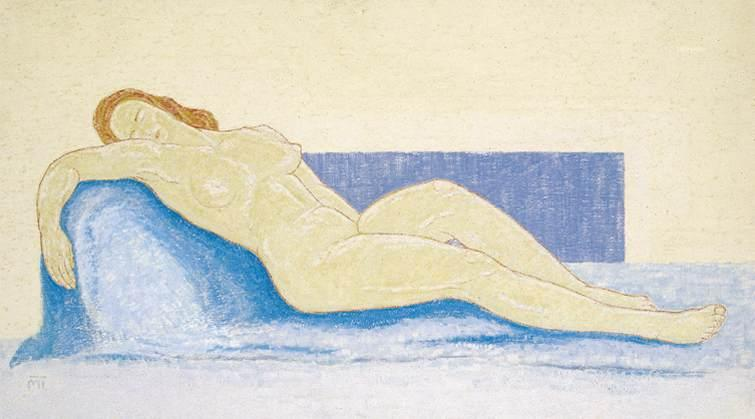Write a detailed description of the given image.
 The image portrays an impressionistic pastel drawing of a nude woman, who is lying on her side on a blue couch. Her head is comfortably resting on her arm, suggesting a state of relaxation. The background is painted in a light yellow color, which contrasts with the blue rectangle positioned behind the couch. The overall composition and use of color are indicative of the figurative art genre. The artist has skillfully used pastel shades to bring out the nuances of the scene, creating a harmonious balance between the subject and her surroundings. The impressionistic style of the artwork further enhances the visual appeal, adding a sense of depth and dimension to the image. The image is a beautiful representation of the human form, captured in a moment of tranquility. 